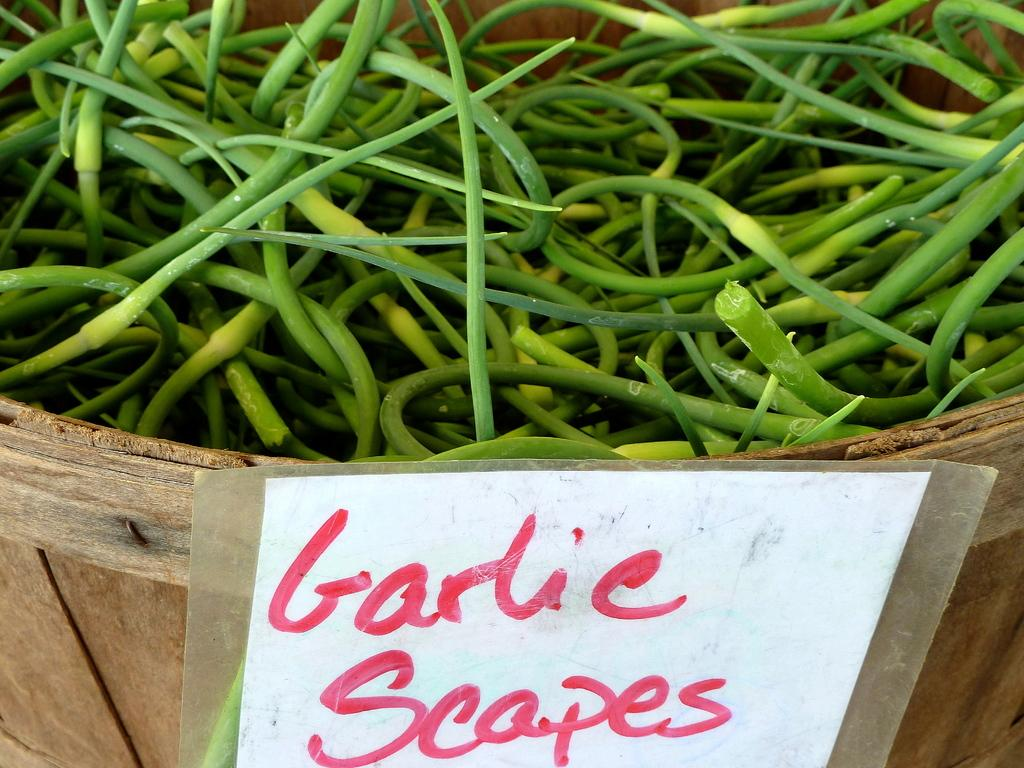What is inside the basket in the image? There are beans in the basket. Is there any additional information attached to the basket? Yes, there is a paper with text attached to the basket. What type of caption is written on the paper attached to the basket? There is no caption present in the image; the paper has text, but it is not specified as a caption. 